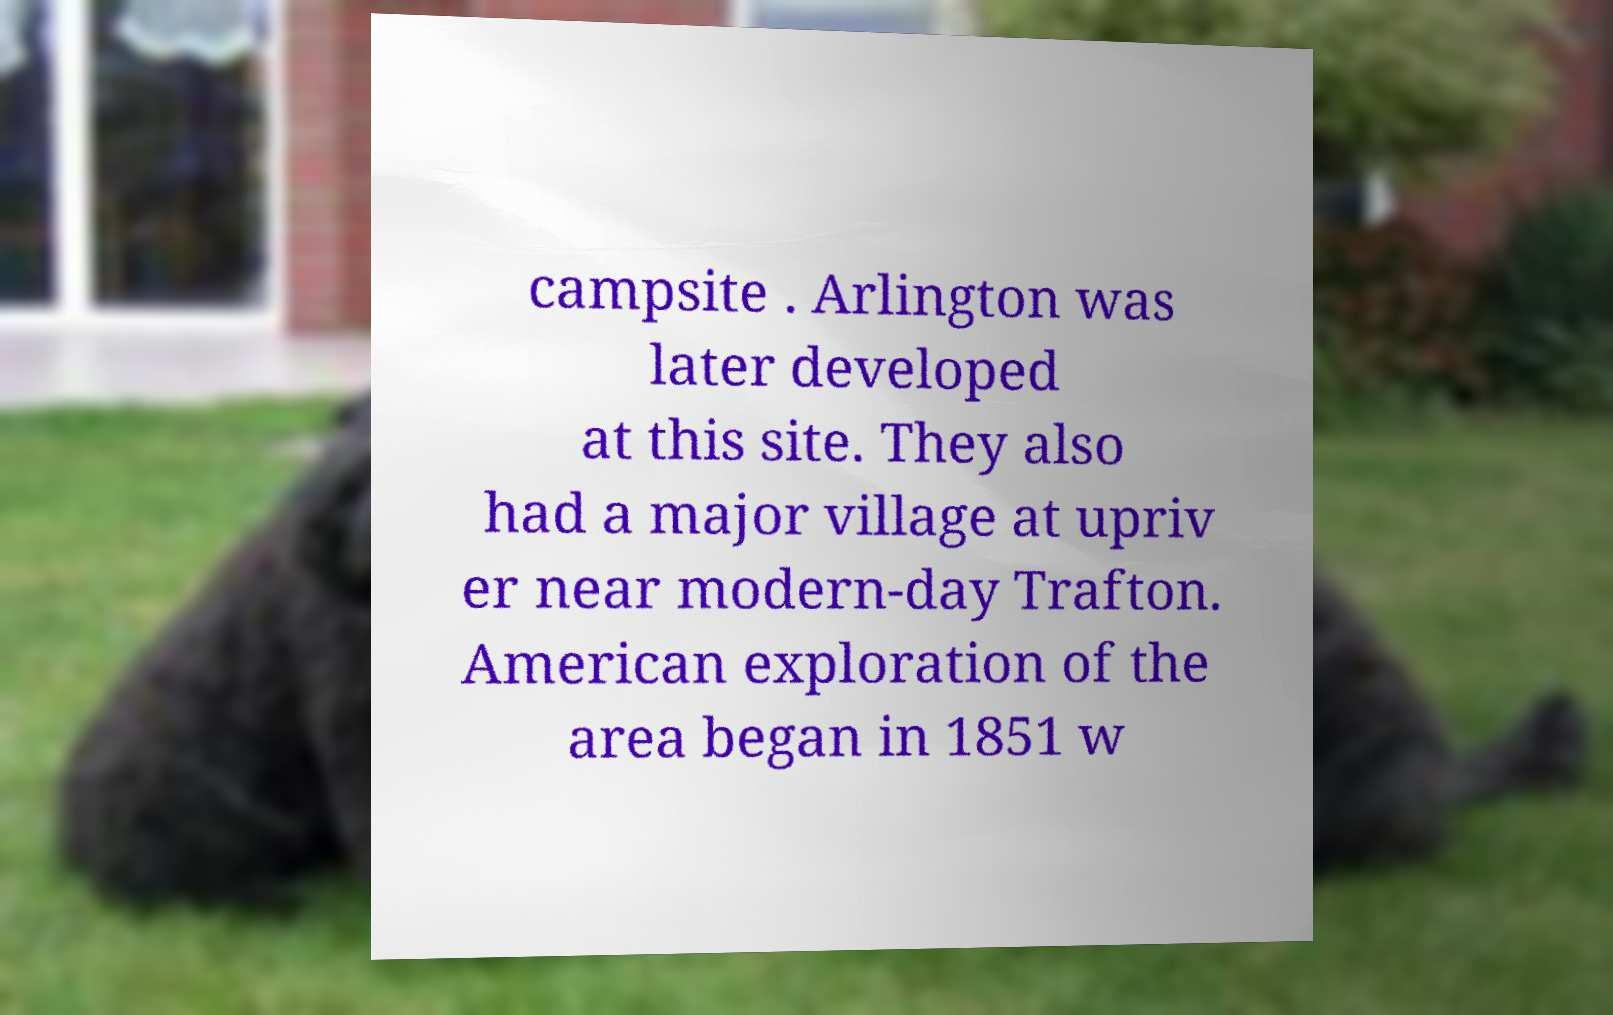I need the written content from this picture converted into text. Can you do that? campsite . Arlington was later developed at this site. They also had a major village at upriv er near modern-day Trafton. American exploration of the area began in 1851 w 